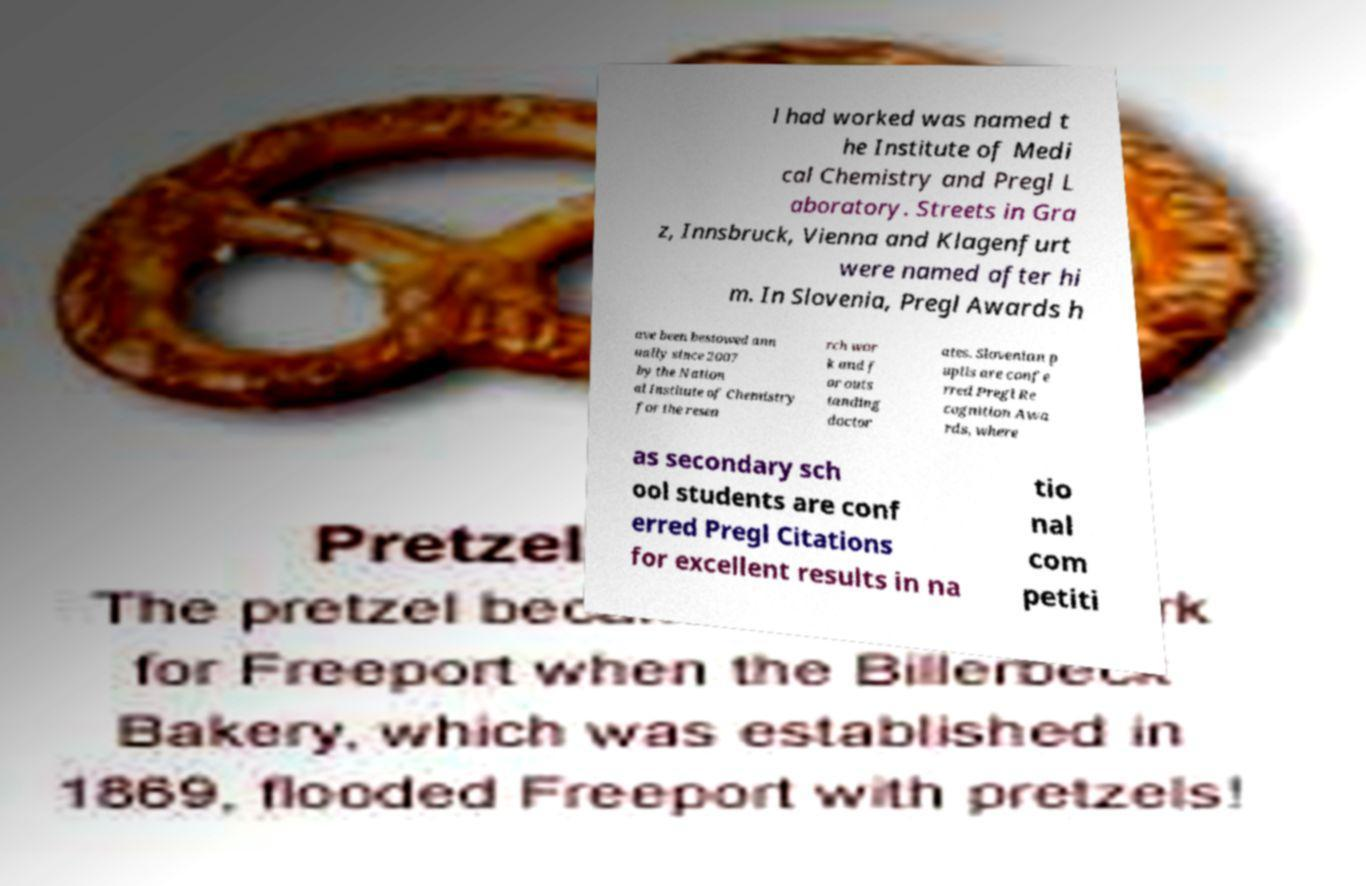Can you accurately transcribe the text from the provided image for me? l had worked was named t he Institute of Medi cal Chemistry and Pregl L aboratory. Streets in Gra z, Innsbruck, Vienna and Klagenfurt were named after hi m. In Slovenia, Pregl Awards h ave been bestowed ann ually since 2007 by the Nation al Institute of Chemistry for the resea rch wor k and f or outs tanding doctor ates. Slovenian p upils are confe rred Pregl Re cognition Awa rds, where as secondary sch ool students are conf erred Pregl Citations for excellent results in na tio nal com petiti 